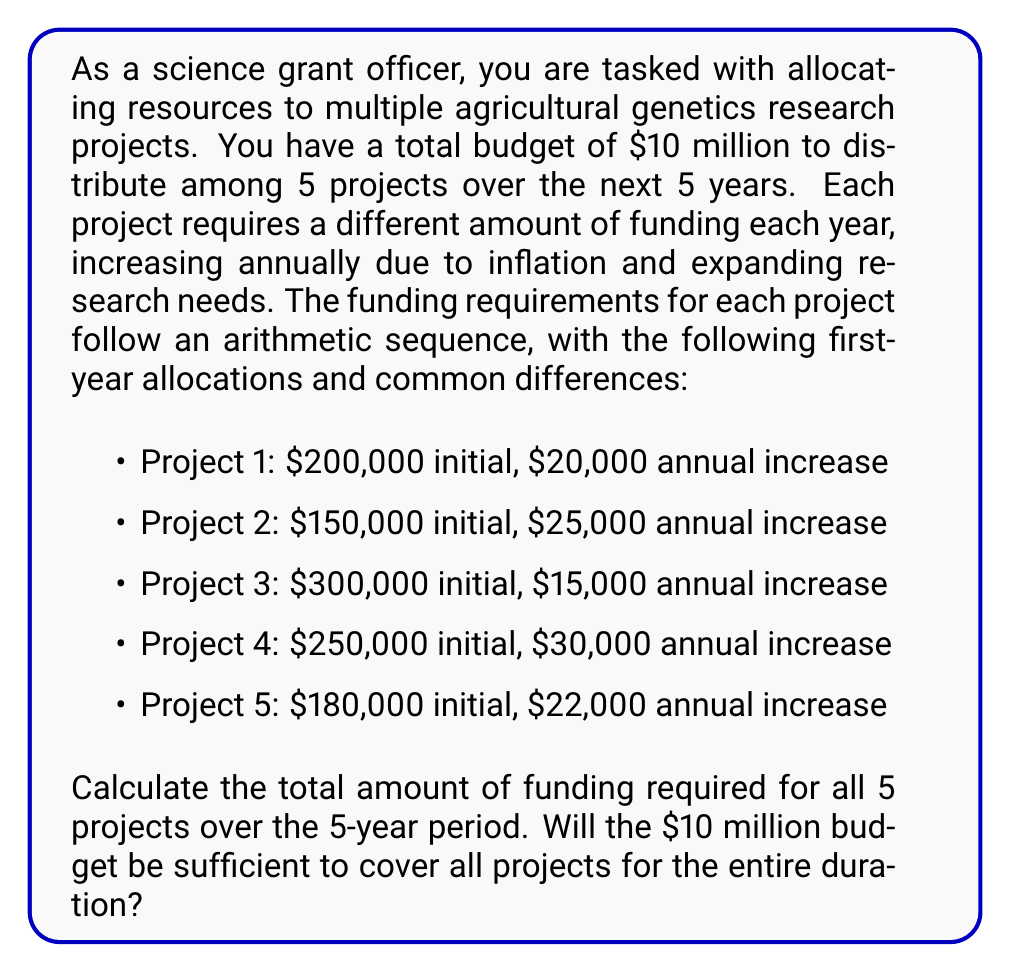Teach me how to tackle this problem. To solve this problem, we need to calculate the sum of arithmetic sequences for each project over 5 years, then add these sums together.

For an arithmetic sequence, the sum of n terms is given by:

$$ S_n = \frac{n}{2}(a_1 + a_n) $$

where $a_1$ is the first term, and $a_n$ is the last term.

For each project, we need to find $a_5$ (the 5th term) using the arithmetic sequence formula:

$$ a_n = a_1 + (n-1)d $$

where $d$ is the common difference.

Let's calculate for each project:

Project 1:
$a_5 = 200,000 + (5-1)(20,000) = 280,000$
$S_5 = \frac{5}{2}(200,000 + 280,000) = 1,200,000$

Project 2:
$a_5 = 150,000 + (5-1)(25,000) = 250,000$
$S_5 = \frac{5}{2}(150,000 + 250,000) = 1,000,000$

Project 3:
$a_5 = 300,000 + (5-1)(15,000) = 360,000$
$S_5 = \frac{5}{2}(300,000 + 360,000) = 1,650,000$

Project 4:
$a_5 = 250,000 + (5-1)(30,000) = 370,000$
$S_5 = \frac{5}{2}(250,000 + 370,000) = 1,550,000$

Project 5:
$a_5 = 180,000 + (5-1)(22,000) = 268,000$
$S_5 = \frac{5}{2}(180,000 + 268,000) = 1,120,000$

Now, we sum up the totals for all projects:

$1,200,000 + 1,000,000 + 1,650,000 + 1,550,000 + 1,120,000 = 6,520,000$

The total funding required for all 5 projects over 5 years is $6,520,000.
Answer: The total funding required for all 5 projects over the 5-year period is $6,520,000. The $10 million budget is sufficient to cover all projects for the entire duration, with $3,480,000 remaining for other expenses or additional funding opportunities. 